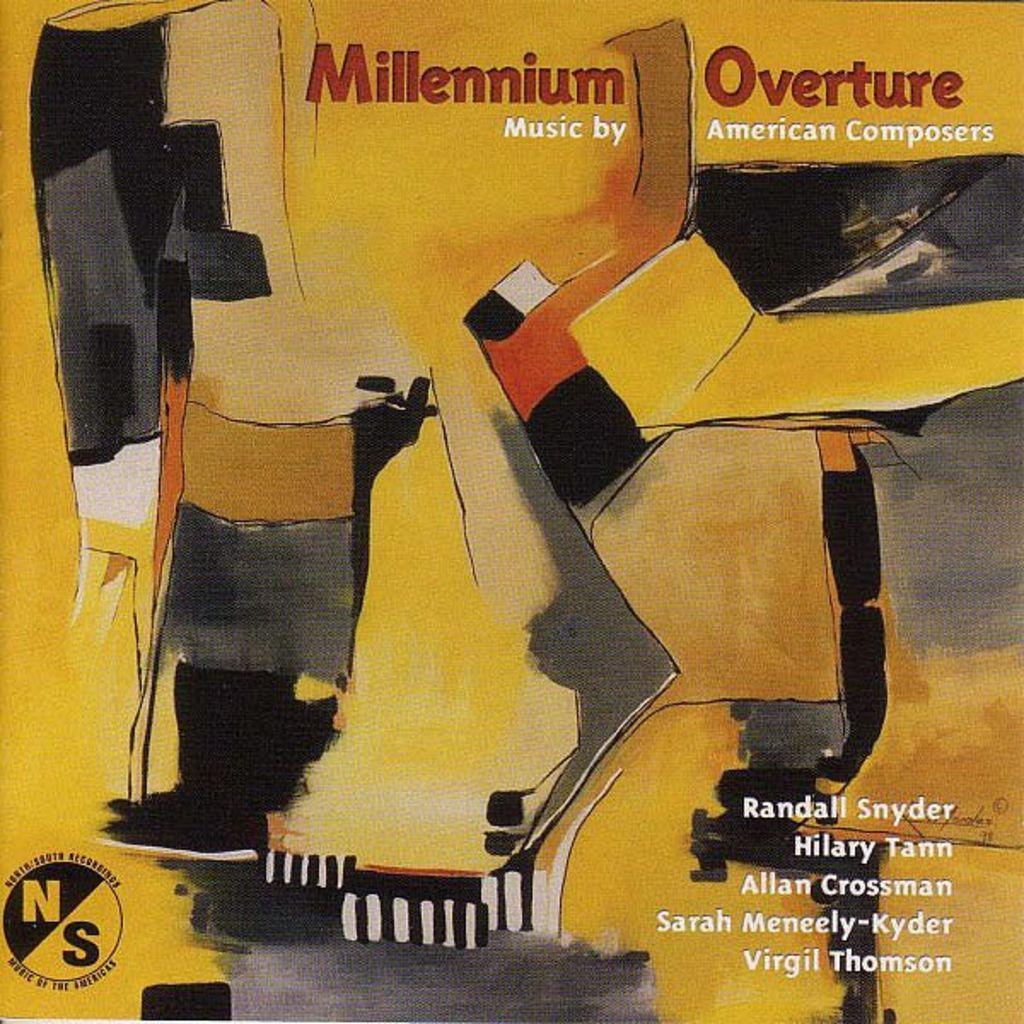<image>
Summarize the visual content of the image. An album called "Millenium Overture" has bright yellow abstract art on the cover. 